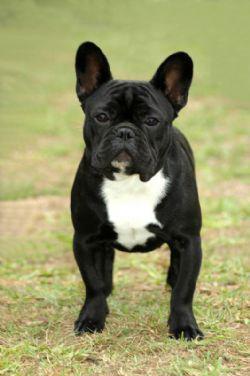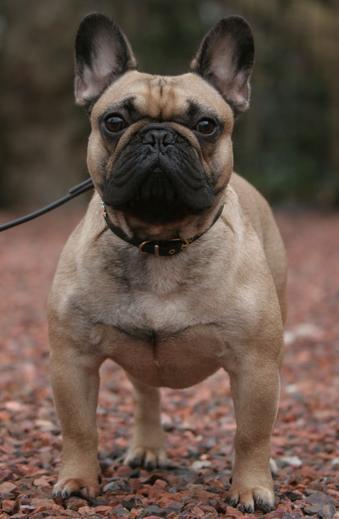The first image is the image on the left, the second image is the image on the right. Assess this claim about the two images: "There is at least one mostly black dog standing on all four legs in the image on the left.". Correct or not? Answer yes or no. Yes. 